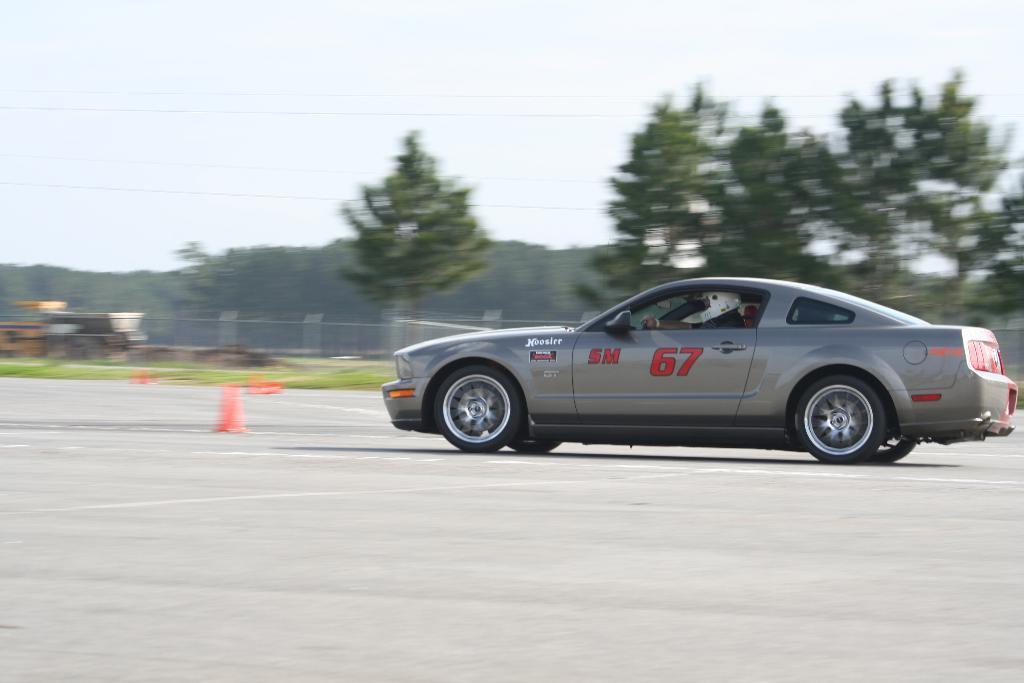Describe this image in one or two sentences. In this image we can see a person wearing a helmet is sitting in a car with some text and numbers on it is placed on the ground. To the left side of the image we can see cone on ground and in the background we can see a fence, a group of trees and the sky. 